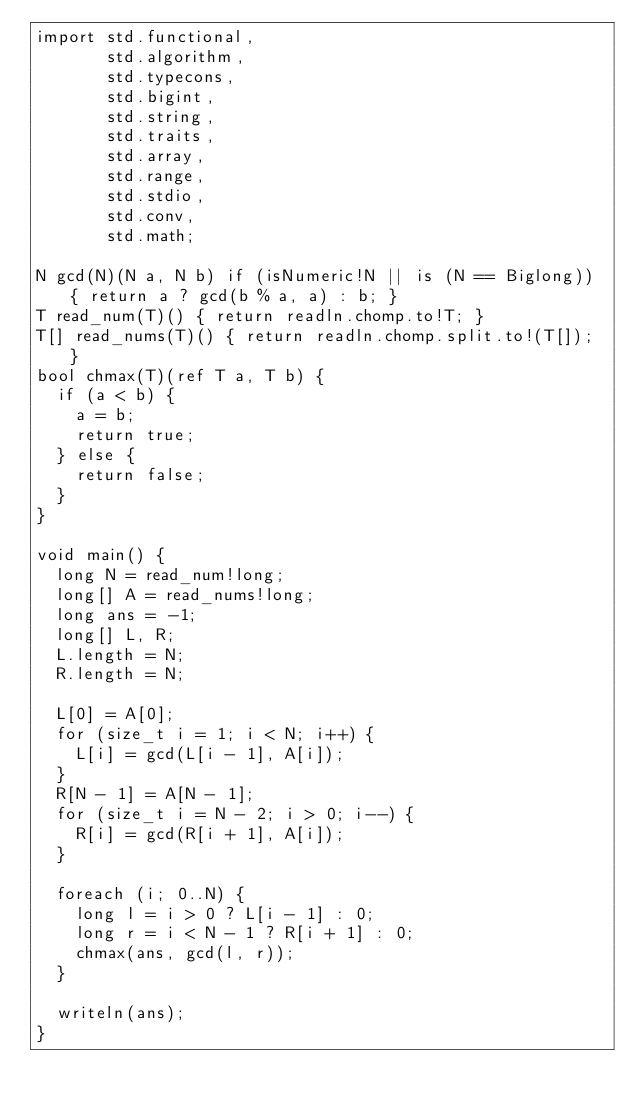<code> <loc_0><loc_0><loc_500><loc_500><_D_>import std.functional,
       std.algorithm,
       std.typecons,
       std.bigint,
       std.string,
       std.traits,
       std.array,
       std.range,
       std.stdio,
       std.conv,
       std.math;

N gcd(N)(N a, N b) if (isNumeric!N || is (N == Biglong)) { return a ? gcd(b % a, a) : b; }
T read_num(T)() { return readln.chomp.to!T; }
T[] read_nums(T)() { return readln.chomp.split.to!(T[]); }
bool chmax(T)(ref T a, T b) {
  if (a < b) {
    a = b;
    return true;
  } else {
    return false;
  }
}

void main() {
  long N = read_num!long;
  long[] A = read_nums!long;
  long ans = -1;
  long[] L, R;
  L.length = N;
  R.length = N;

  L[0] = A[0];
  for (size_t i = 1; i < N; i++) {
    L[i] = gcd(L[i - 1], A[i]);
  }
  R[N - 1] = A[N - 1];
  for (size_t i = N - 2; i > 0; i--) {
    R[i] = gcd(R[i + 1], A[i]);
  }

  foreach (i; 0..N) {
    long l = i > 0 ? L[i - 1] : 0;
    long r = i < N - 1 ? R[i + 1] : 0;
    chmax(ans, gcd(l, r));
  }

  writeln(ans);
}</code> 